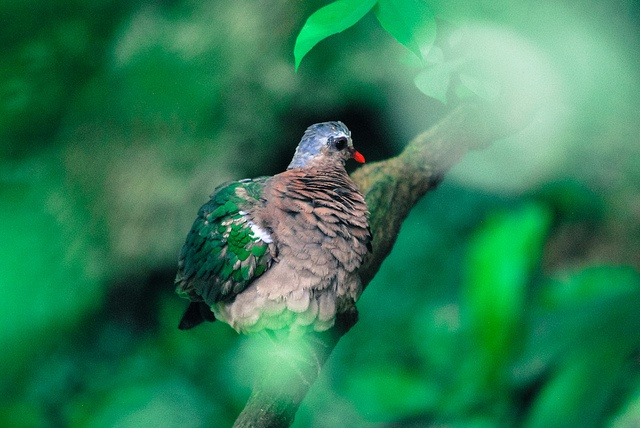Describe the objects in this image and their specific colors. I can see a bird in darkgreen, darkgray, black, gray, and teal tones in this image. 